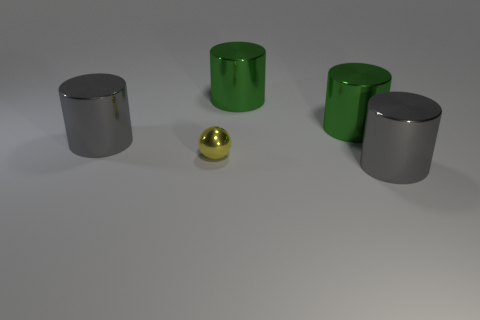Are the big gray cylinder that is to the right of the small yellow object and the gray object behind the yellow metal thing made of the same material?
Provide a short and direct response. Yes. Is the material of the gray cylinder that is on the left side of the tiny yellow metallic object the same as the tiny sphere?
Keep it short and to the point. Yes. Is the number of big gray things that are left of the small yellow object less than the number of big green shiny objects?
Your answer should be compact. Yes. Is there a tiny yellow cube made of the same material as the yellow ball?
Give a very brief answer. No. Is there a cylinder that has the same color as the tiny metallic sphere?
Give a very brief answer. No. There is a tiny yellow metallic thing; how many small metal balls are on the right side of it?
Provide a short and direct response. 0. There is a large object in front of the big metal cylinder to the left of the yellow shiny ball; what is its color?
Provide a short and direct response. Gray. Are there any brown matte cylinders?
Provide a short and direct response. No. There is a big object on the left side of the small yellow metal thing; how many gray shiny things are in front of it?
Make the answer very short. 1. How many things are behind the yellow sphere and right of the tiny metal object?
Provide a short and direct response. 2. 